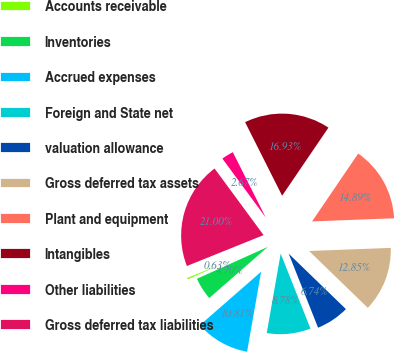Convert chart to OTSL. <chart><loc_0><loc_0><loc_500><loc_500><pie_chart><fcel>Accounts receivable<fcel>Inventories<fcel>Accrued expenses<fcel>Foreign and State net<fcel>valuation allowance<fcel>Gross deferred tax assets<fcel>Plant and equipment<fcel>Intangibles<fcel>Other liabilities<fcel>Gross deferred tax liabilities<nl><fcel>0.63%<fcel>4.7%<fcel>10.81%<fcel>8.78%<fcel>6.74%<fcel>12.85%<fcel>14.89%<fcel>16.93%<fcel>2.67%<fcel>21.0%<nl></chart> 